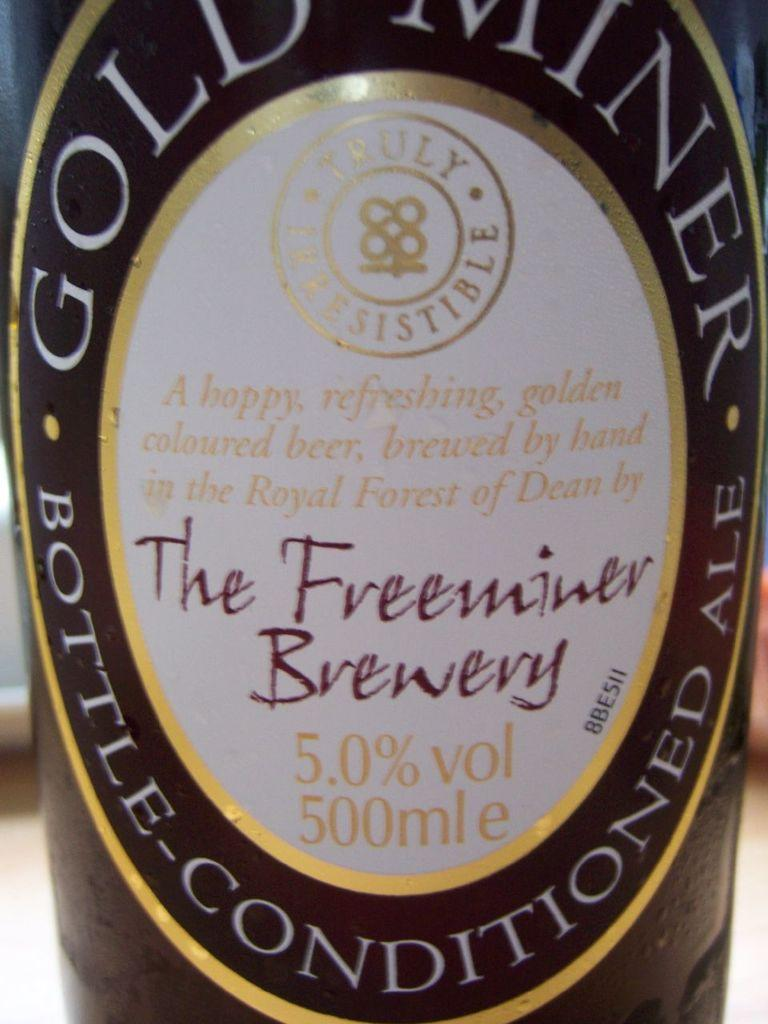<image>
Relay a brief, clear account of the picture shown. a bottle of alcohol from the freeminer brewery 